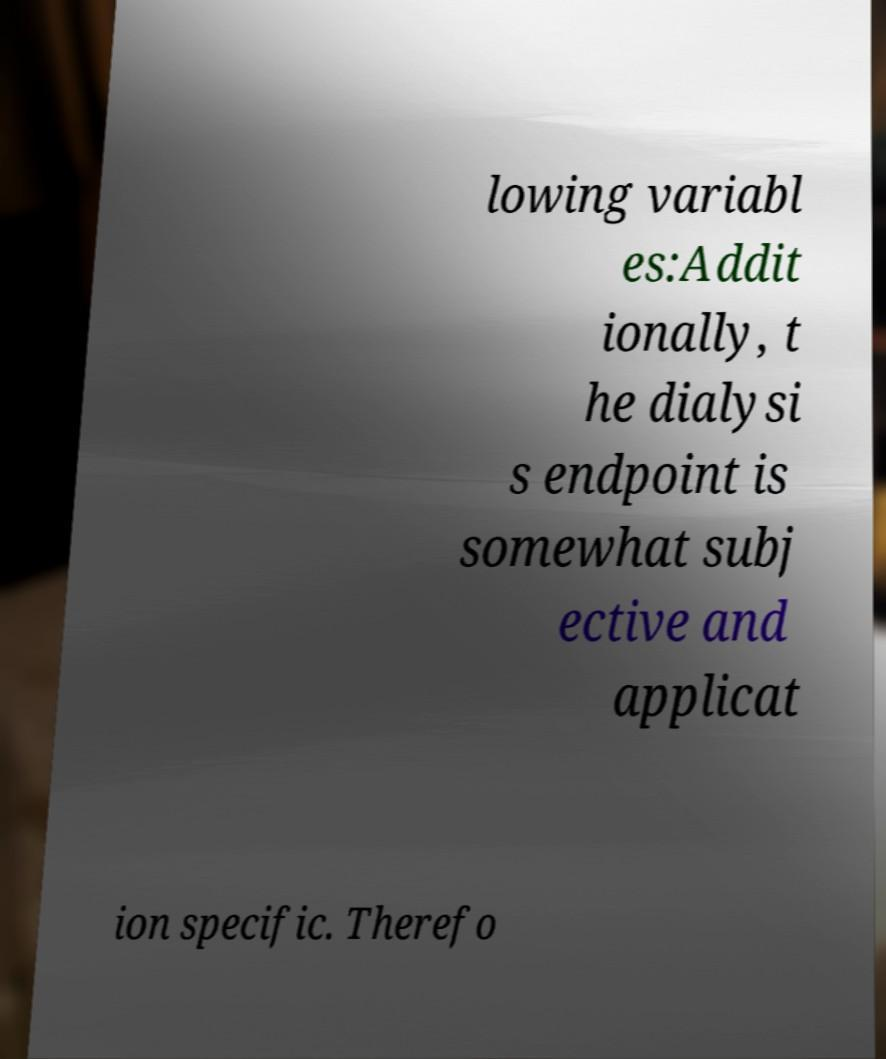Could you extract and type out the text from this image? lowing variabl es:Addit ionally, t he dialysi s endpoint is somewhat subj ective and applicat ion specific. Therefo 